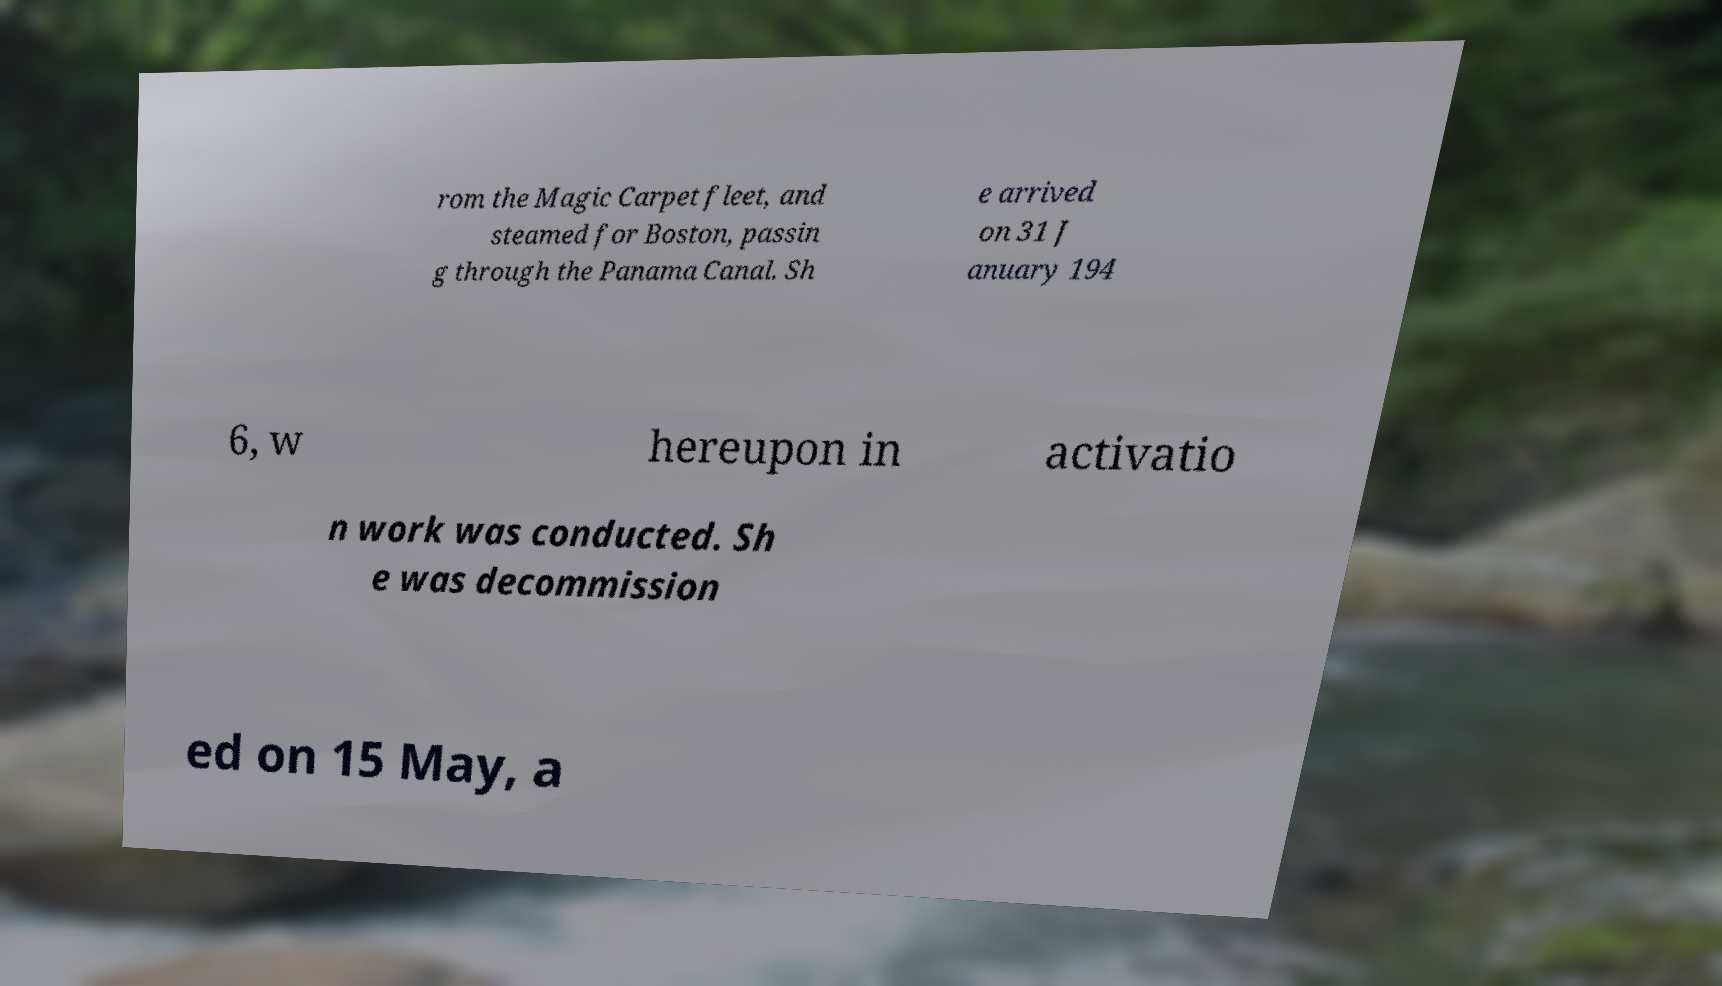I need the written content from this picture converted into text. Can you do that? rom the Magic Carpet fleet, and steamed for Boston, passin g through the Panama Canal. Sh e arrived on 31 J anuary 194 6, w hereupon in activatio n work was conducted. Sh e was decommission ed on 15 May, a 